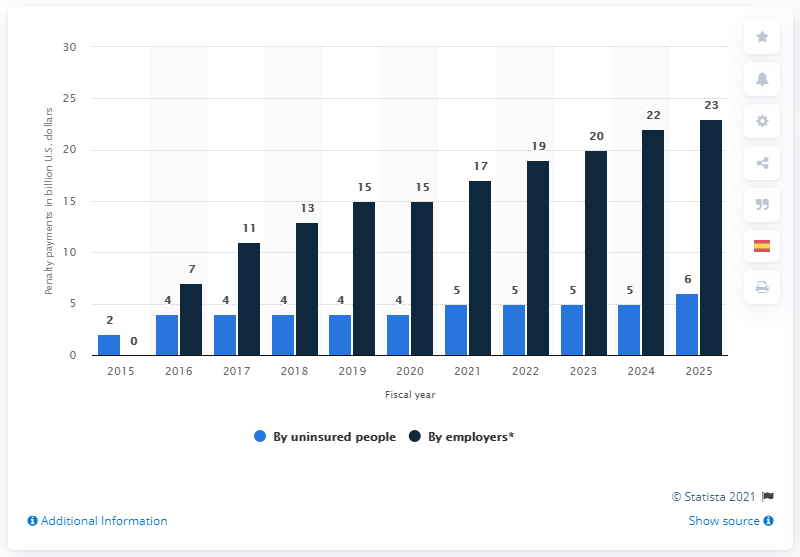Outline some significant characteristics in this image. By 2018, the penalty payments for employers are expected to reach $13 per employee, according to projections. 